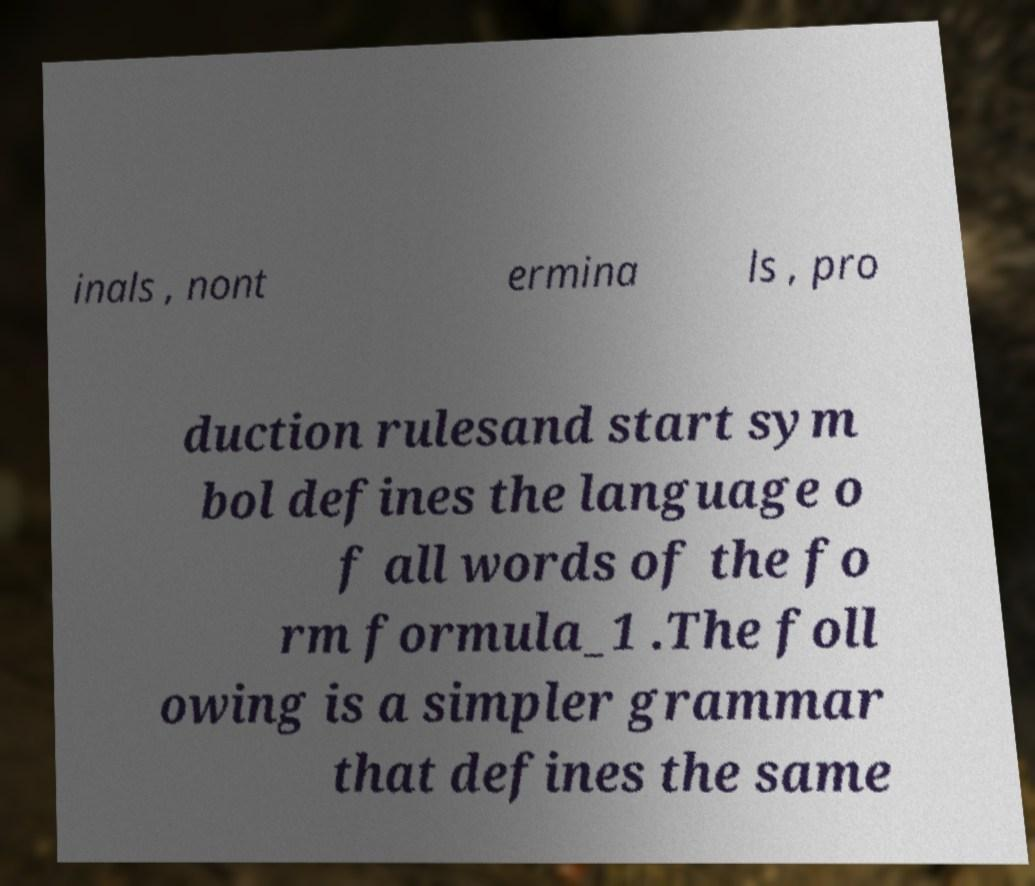Can you accurately transcribe the text from the provided image for me? inals , nont ermina ls , pro duction rulesand start sym bol defines the language o f all words of the fo rm formula_1 .The foll owing is a simpler grammar that defines the same 